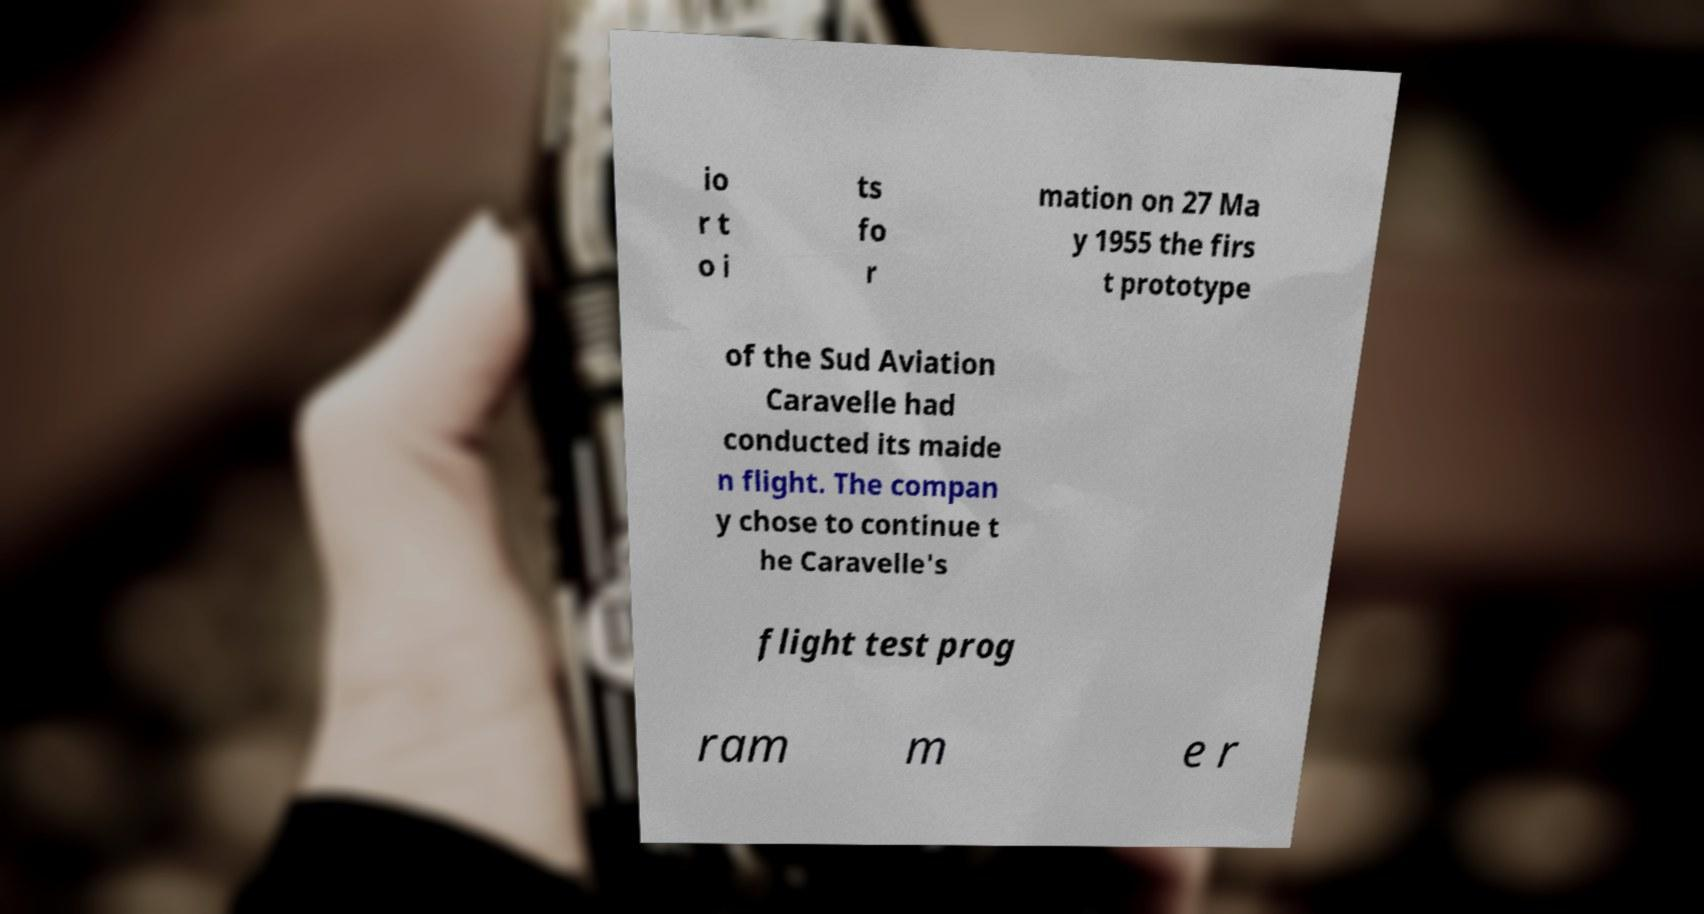What messages or text are displayed in this image? I need them in a readable, typed format. io r t o i ts fo r mation on 27 Ma y 1955 the firs t prototype of the Sud Aviation Caravelle had conducted its maide n flight. The compan y chose to continue t he Caravelle's flight test prog ram m e r 